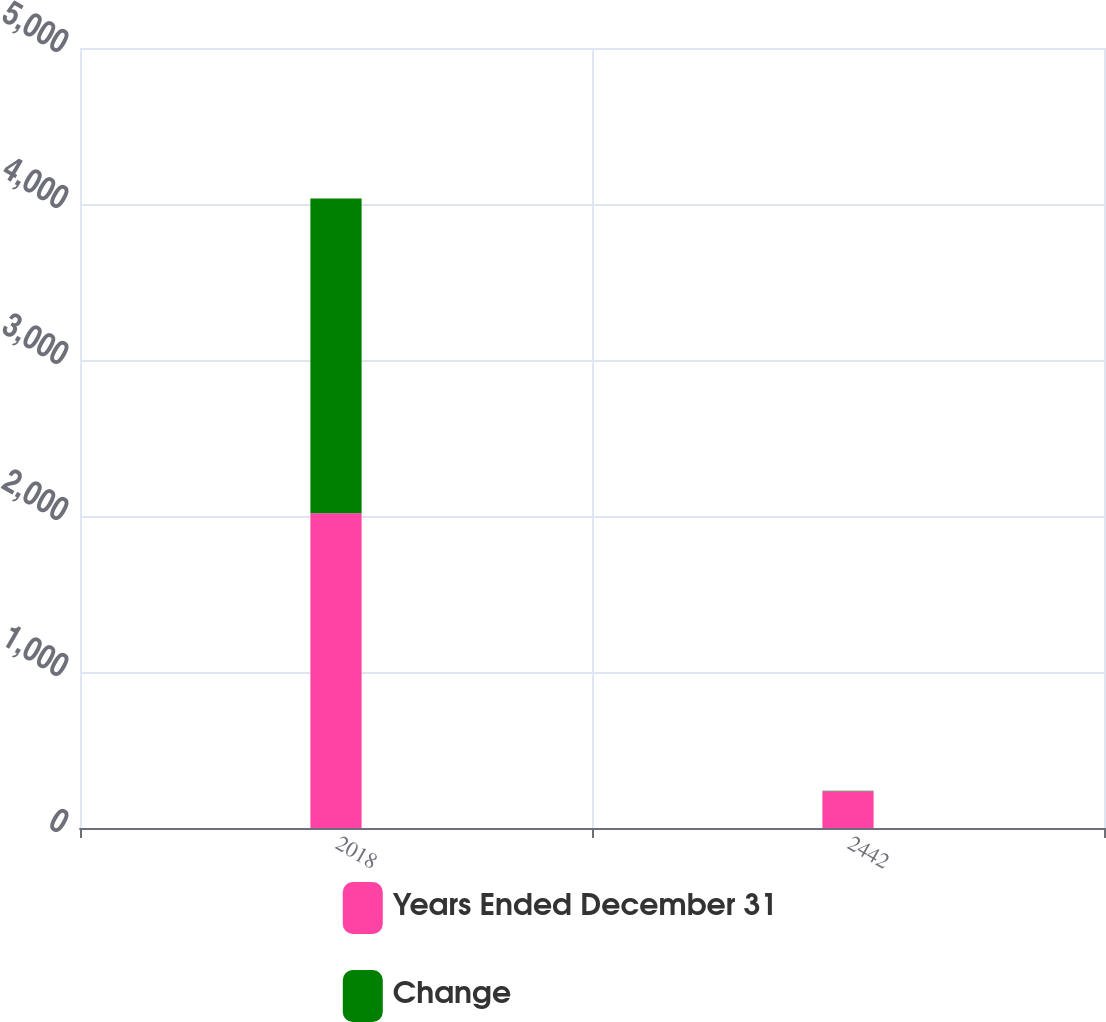Convert chart to OTSL. <chart><loc_0><loc_0><loc_500><loc_500><stacked_bar_chart><ecel><fcel>2018<fcel>2442<nl><fcel>Years Ended December 31<fcel>2017<fcel>235.1<nl><fcel>Change<fcel>2018<fcel>3.9<nl></chart> 